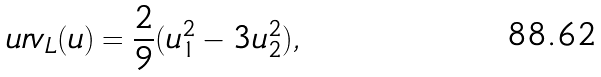<formula> <loc_0><loc_0><loc_500><loc_500>u r v _ { L } ( u ) = \frac { 2 } { 9 } ( u _ { 1 } ^ { 2 } - 3 u _ { 2 } ^ { 2 } ) ,</formula> 